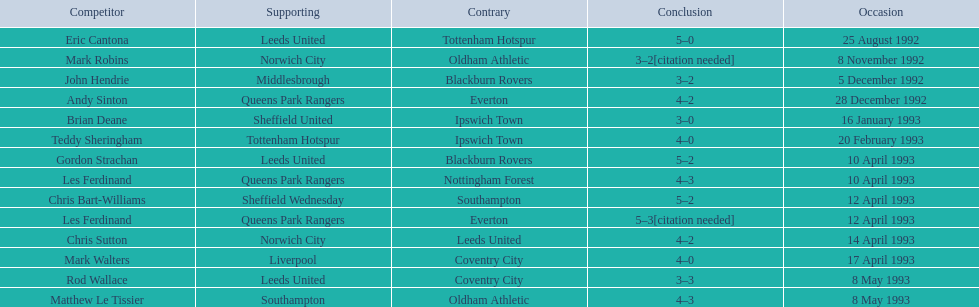What are the results? 5–0, 3–2[citation needed], 3–2, 4–2, 3–0, 4–0, 5–2, 4–3, 5–2, 5–3[citation needed], 4–2, 4–0, 3–3, 4–3. What result did mark robins have? 3–2[citation needed]. What other player had that result? John Hendrie. 